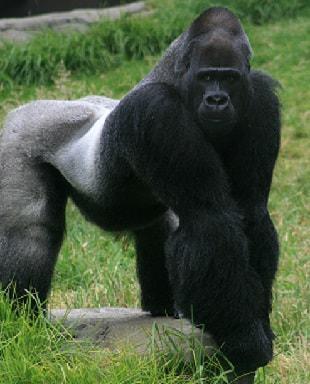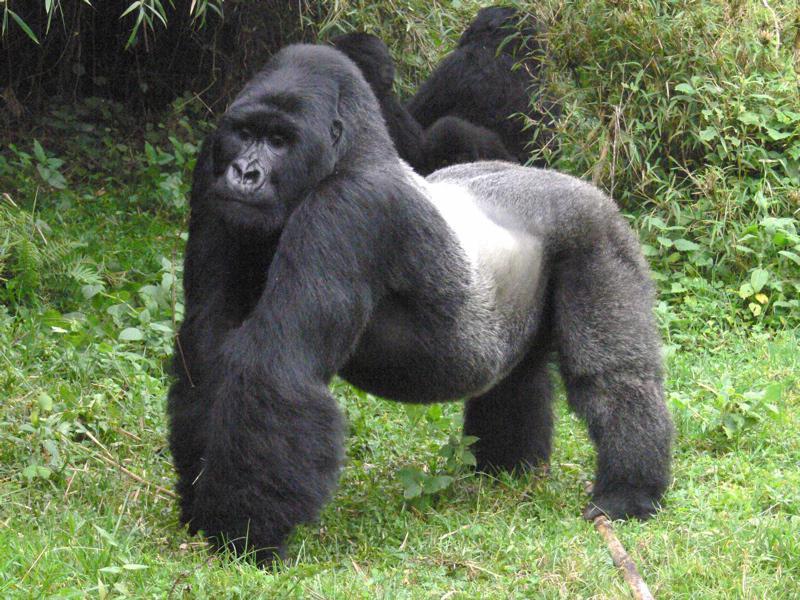The first image is the image on the left, the second image is the image on the right. Assess this claim about the two images: "There are two gorillas laying down". Correct or not? Answer yes or no. No. The first image is the image on the left, the second image is the image on the right. For the images shown, is this caption "The right image contains a gorilla lying on the grass with its head facing forward and the top of its head on the right." true? Answer yes or no. No. 